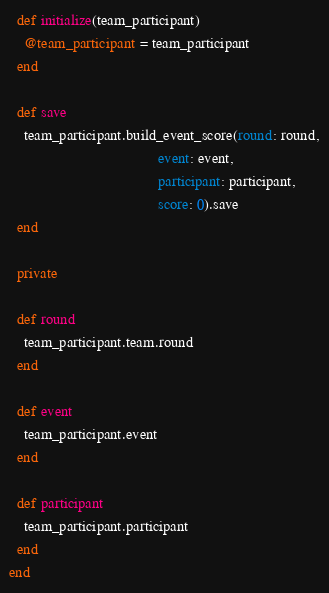Convert code to text. <code><loc_0><loc_0><loc_500><loc_500><_Ruby_>  def initialize(team_participant)
    @team_participant = team_participant
  end

  def save
    team_participant.build_event_score(round: round,
                                       event: event,
                                       participant: participant,
                                       score: 0).save
  end

  private

  def round
    team_participant.team.round
  end

  def event
    team_participant.event
  end

  def participant
    team_participant.participant
  end
end
</code> 